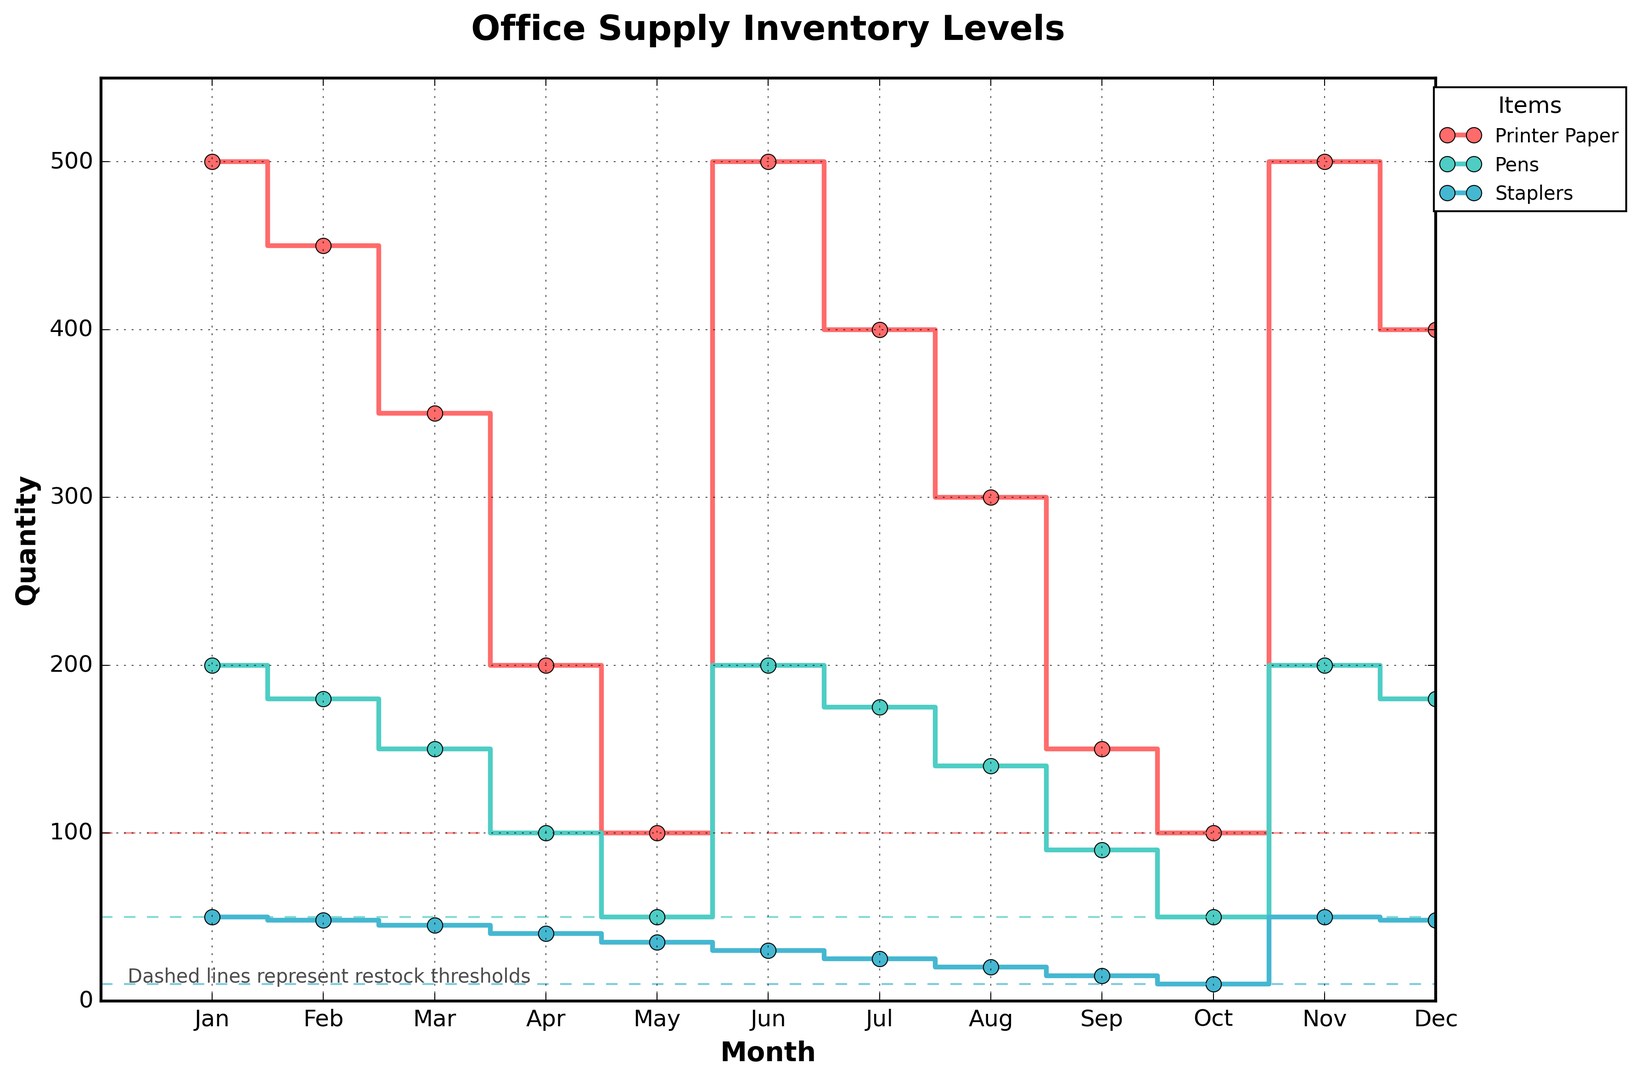What is the restock threshold for printer paper? The plot shows that the dashed line representing the restock threshold for printer paper is at the 100 quantity level.
Answer: 100 During which months did the quantity of pens fall below the restock threshold? The dashed line representing the restock threshold for pens is at the 50 quantity level. The plot shows that the quantity of pens fell to or below this level in May and October.
Answer: May and October Which item experienced the highest inventory quantity at any point in the year? The plot shows that printer paper reached a peak inventory quantity of 500 in January, June, and November. This is the highest inventory level among all items.
Answer: Printer paper In which month did staplers reach their restock threshold? The plot shows that the quantity of staplers reached exactly 10, which is the restock threshold, in October.
Answer: October Compare the lowest inventory levels reached by printer paper and pens. Which month did each occur in, and what were the values? The lowest inventory level for printer paper was 100 in May and October. The lowest inventory level for pens was 50 in May and October. Both items reached their lowest inventory levels in May and October at 100 for printer paper and 50 for pens, respectively.
Answer: Printer paper: May, October, 100; Pens: May, October, 50 What is the difference between the highest and lowest inventory levels for staplers? The highest inventory level for staplers is 50 in January and November. The lowest inventory level is 10 in October. The difference is 50 - 10 = 40.
Answer: 40 What are the quantities of printer paper in March and September, and what is their average? The plot shows quantities of printer paper in March and September are 350 and 150 respectively. The average is (350 + 150) / 2 = 250.
Answer: 250 Which item had consistent restocking every sixth month, and what were those months? The plot shows that both printer paper and pens had sharp increases in their quantities every sixth month. These months are June and December.
Answer: Printer paper and pens; June and December What overall trend do you observe in the inventory levels of staplers? The plot shows a consistent decline in the inventory levels of staplers from January to October, reaching the restock threshold in October, followed by a restocking in November and a slight decrease in December.
Answer: Overall decline with restock in November When did the quantity of printer paper drop to its restock threshold, and how frequently did this happen? The plot shows that the quantity of printer paper dropped to its restock threshold of 100 in May and October. This happened twice within the year.
Answer: May and October; twice 